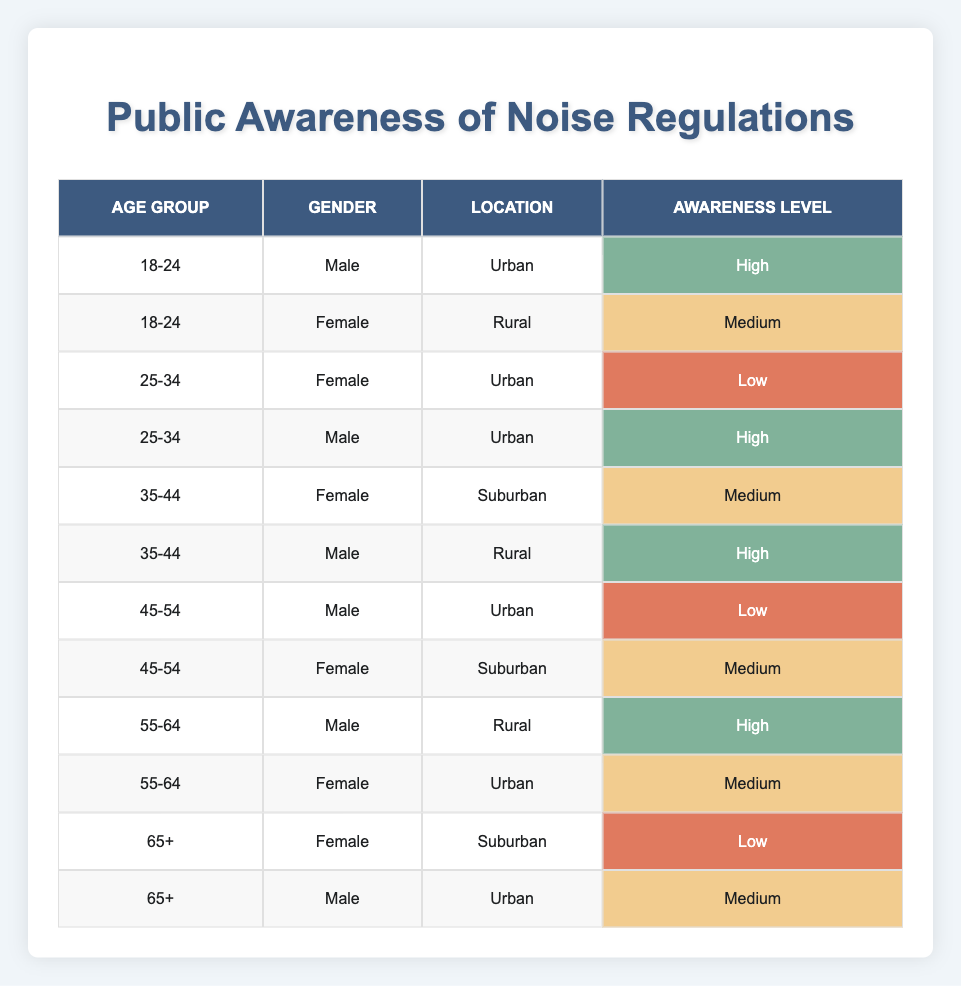What is the awareness level for males aged 25-34 in an urban location? The table shows that the awareness level for males aged 25-34 in an urban location is noted as "High."
Answer: High How many individuals in the age group 35-44 have a high level of awareness? In the 35-44 age group, there is one male with high awareness (in rural) and one female (in suburban) with medium awareness; therefore, only the male counts. Thus, there is 1 individual with high awareness.
Answer: 1 What percentage of females in the age group 55-64 have a medium awareness level? In the age group 55-64, there are two females: one has a medium awareness level, making the percentage (1/2) * 100 = 50%.
Answer: 50% Is there any male in the 45-54 age group who has high awareness? The table indicates that there is no male in the 45-54 age group listed with high awareness; instead, there are two males, both with low and medium levels of awareness.
Answer: No Which location has the most individuals reporting high awareness among the age group 35-44? In the age group 35-44, there are 2 males (one in rural and one in suburban) with high awareness. The rural location has the most (1 high awareness male).
Answer: Rural location What is the total number of individuals reporting a low awareness level across all age groups? The table lists individuals with low awareness levels: 1 male aged 45-54 and 1 female aged 65+. Thus, the total equals 2 individuals.
Answer: 2 How many individuals in the urban location have medium awareness? The table indicates those with medium awareness in urban locations: 1 female aged 18-24, 1 female aged 55-64, and 1 male aged 65+. So, the total is 3 individuals.
Answer: 3 In which age group do the highest number of individuals report a high awareness level? The age groups 25-34 and 35-44 each have 2 individuals reporting high awareness (1 male from each group in urban and rural), which is the highest.
Answer: 25-34 and 35-44 What is the average age of individuals reporting medium awareness? The age groups with medium awareness are 18-24, 35-44, 45-54, and 65+. The corresponding ages are averaged: (21 + 38 + 49.5 + 70) / 4 = 44.875, rounded to 45.
Answer: 45 